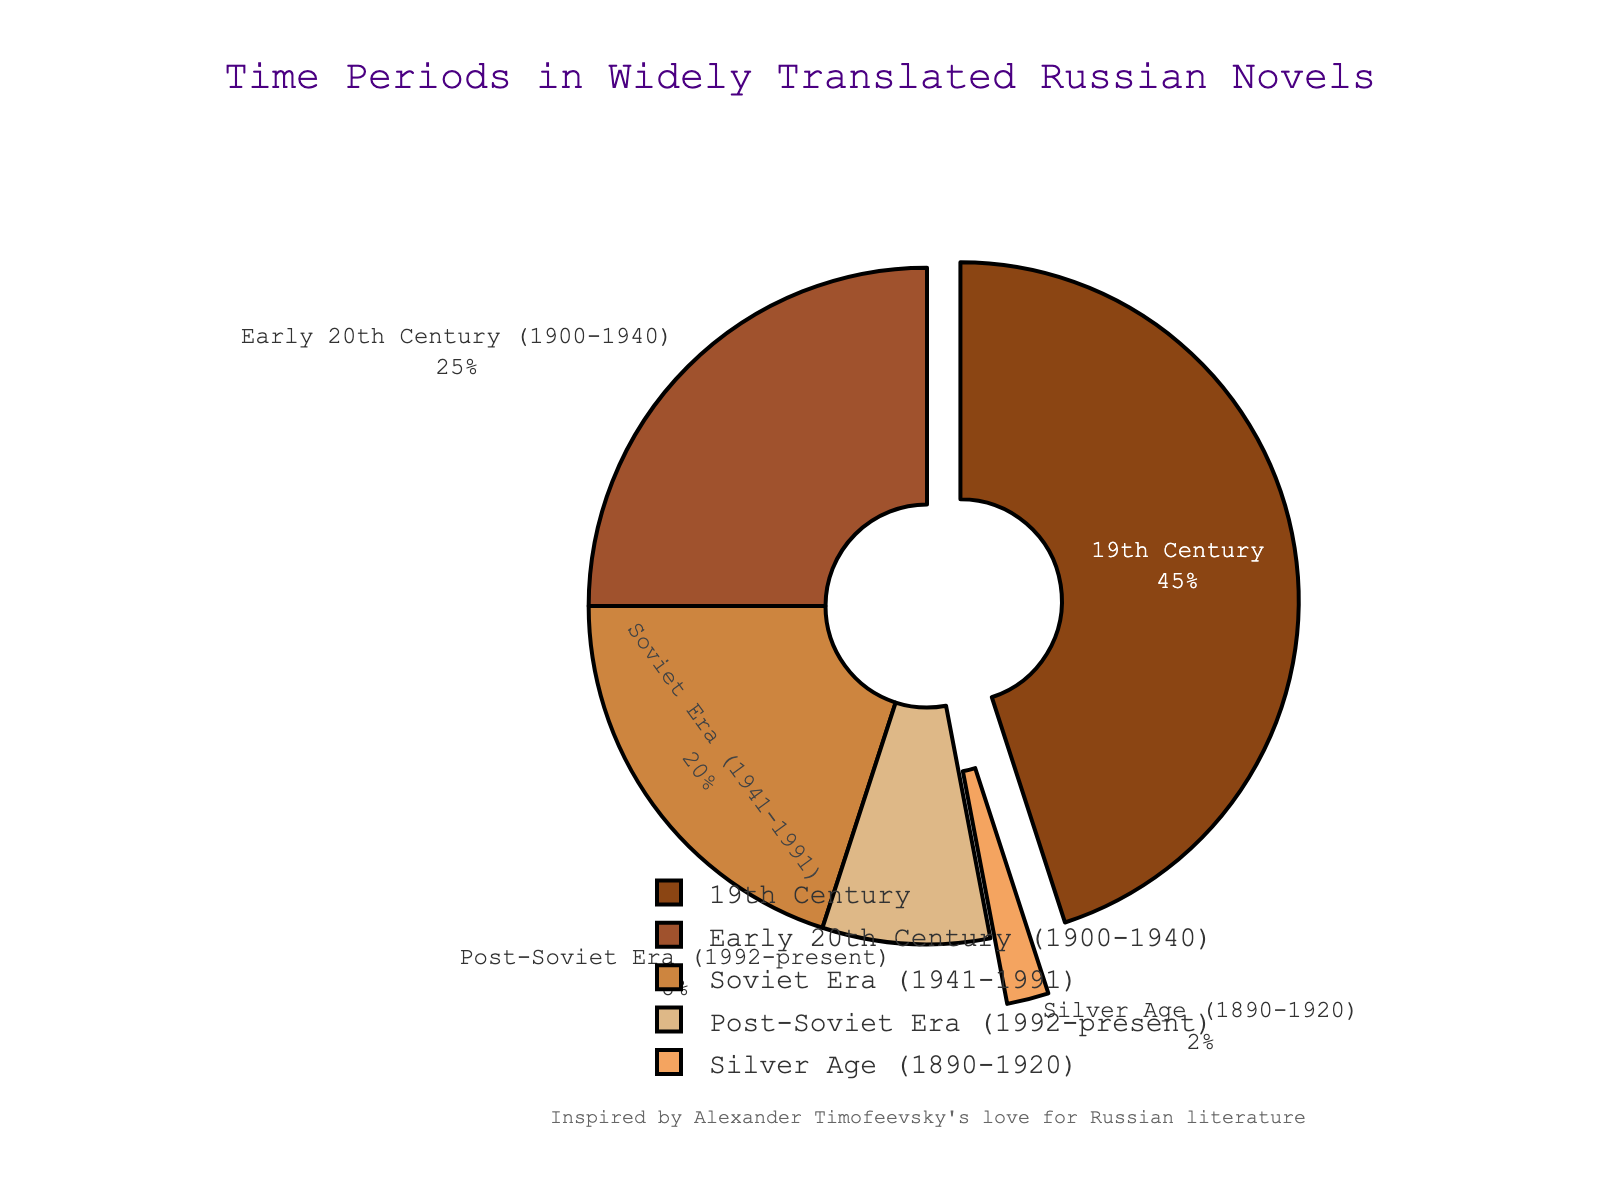Which time period represents the largest percentage? The figure shows a pie chart where each section represents a different time period along with its percentage. By identifying the section with the largest percentage, we see that the 19th Century has the most significant portion at 45%.
Answer: 19th Century How much smaller is the Silver Age compared to the Soviet Era percentage-wise? The figure shows the percentages for each time period. The percentage for the Silver Age is 2%, and the Soviet Era is 20%. Subtracting 2% from 20% gives us the difference.
Answer: 18% What is the combined percentage of novels from the 19th Century and the Soviet Era? To find the combined percentage, sum the percentages of the 19th Century and Soviet Era. The 19th Century is 45% and the Soviet Era is 20%, so 45% + 20% = 65%.
Answer: 65% Which time period has the second smallest representation? The graph indicates the sizes of different slices. The time period with the second smallest slice is the Post-Soviet Era, represented by 8%.
Answer: Post-Soviet Era How do the percentages of the Early 20th Century and Post-Soviet Era compare? The pie chart shows the Early 20th Century at 25% and the Post-Soviet Era at 8%. To compare, we see that 25% is greater than 8%.
Answer: Early 20th Century is greater If the Soviet Era and Post-Soviet Era percentages are combined, would they surpass the 19th Century? To determine this, add the percentages of the Soviet Era (20%) and Post-Soviet Era (8%), which equals 28%. Compare this with the 19th Century, which is 45%. Since 28% is less than 45%, they do not surpass the 19th Century.
Answer: No What is the average percentage of the Silver Age and Early 20th Century? Average percentage is found by adding the percentages of the Silver Age (2%) and Early 20th Century (25%) and then dividing by 2. (2% + 25%) / 2 = 13.5%.
Answer: 13.5% Which sections are visually pulled out in the pie chart? In the figure, the 19th Century and Silver Age sections are visually pulled out from the rest of the pie chart, making them stand out.
Answer: 19th Century and Silver Age What is the percentage difference between the most and least represented time periods? The most represented time period is the 19th Century at 45%, and the least represented is the Silver Age at 2%. Subtracting 2% from 45% gives the difference.
Answer: 43% 